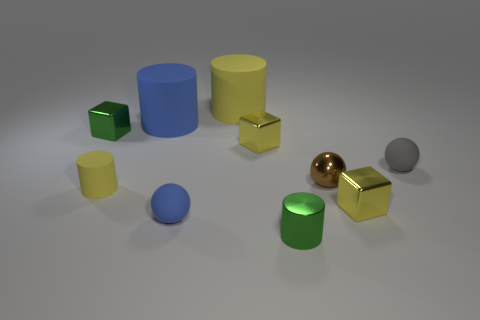What number of tiny rubber balls have the same color as the metallic cylinder?
Make the answer very short. 0. Are there fewer green shiny cubes than big purple metal spheres?
Offer a very short reply. No. Do the tiny brown sphere and the big blue cylinder have the same material?
Provide a short and direct response. No. What number of other objects are the same size as the green metal block?
Your answer should be compact. 7. There is a tiny cylinder that is behind the green object that is in front of the tiny yellow rubber cylinder; what is its color?
Your answer should be compact. Yellow. What number of other objects are there of the same shape as the tiny blue object?
Provide a short and direct response. 2. Is there a large blue thing that has the same material as the green cylinder?
Ensure brevity in your answer.  No. What is the material of the yellow thing that is the same size as the blue rubber cylinder?
Your response must be concise. Rubber. The shiny ball that is on the right side of the tiny green object to the right of the blue matte object that is in front of the green metallic cube is what color?
Offer a terse response. Brown. There is a small green metallic thing right of the green shiny cube; is it the same shape as the tiny yellow metallic thing that is on the left side of the small brown thing?
Keep it short and to the point. No. 